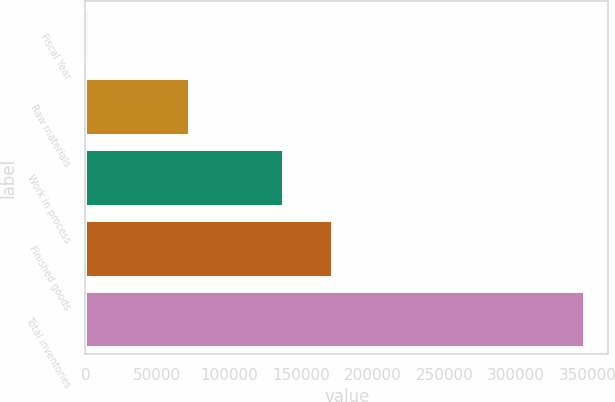Convert chart. <chart><loc_0><loc_0><loc_500><loc_500><bar_chart><fcel>Fiscal Year<fcel>Raw materials<fcel>Work in process<fcel>Finished goods<fcel>Total inventories<nl><fcel>2015<fcel>71863<fcel>137306<fcel>171794<fcel>346900<nl></chart> 